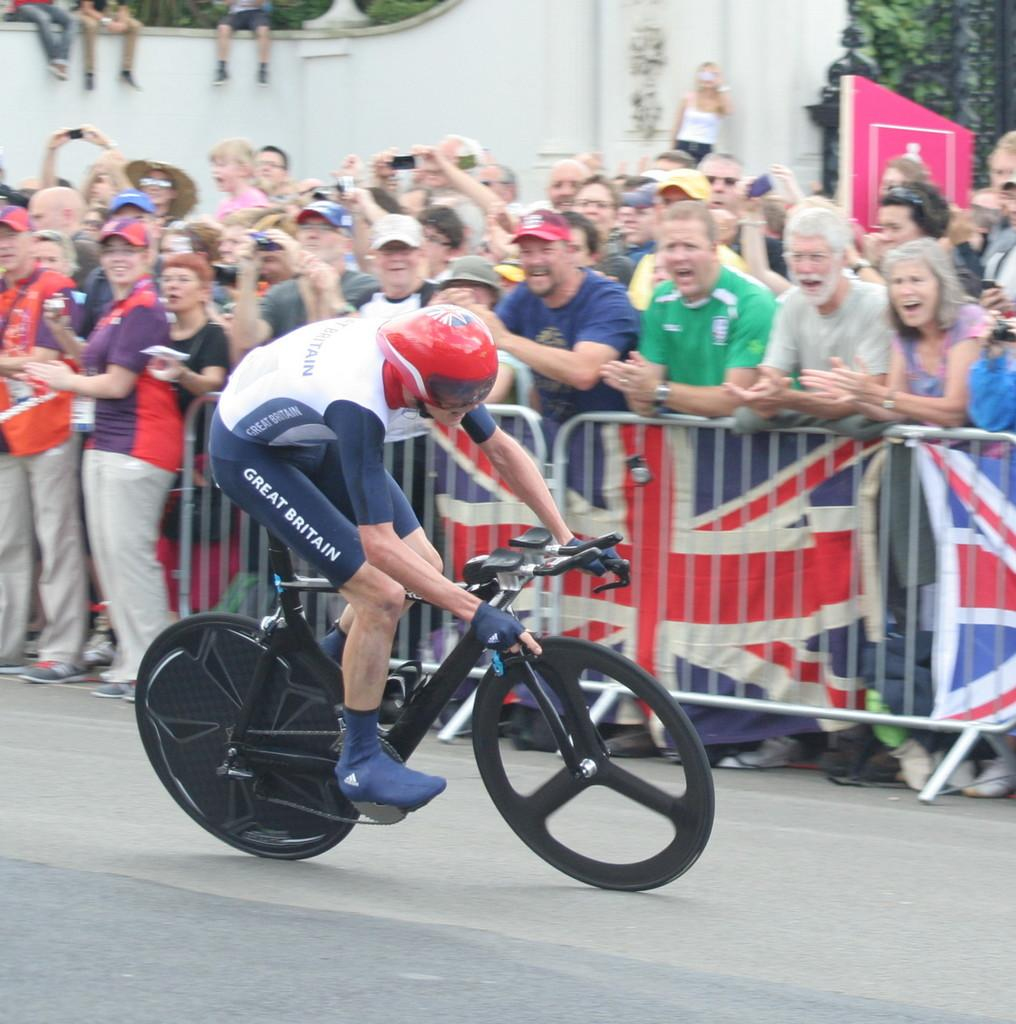Who is the main subject in the image? There is a man in the image. What is the man doing in the image? The man is riding a bicycle. What type of event is the man participating in? The bicycle is part of a sports event. Are there any other people present in the image? Yes, there are people beside the man. What are the people doing in relation to the man? The people are encouraging the man. What type of berry is the man holding in the image? There is no berry present in the image; the man is riding a bicycle as part of a sports event. 